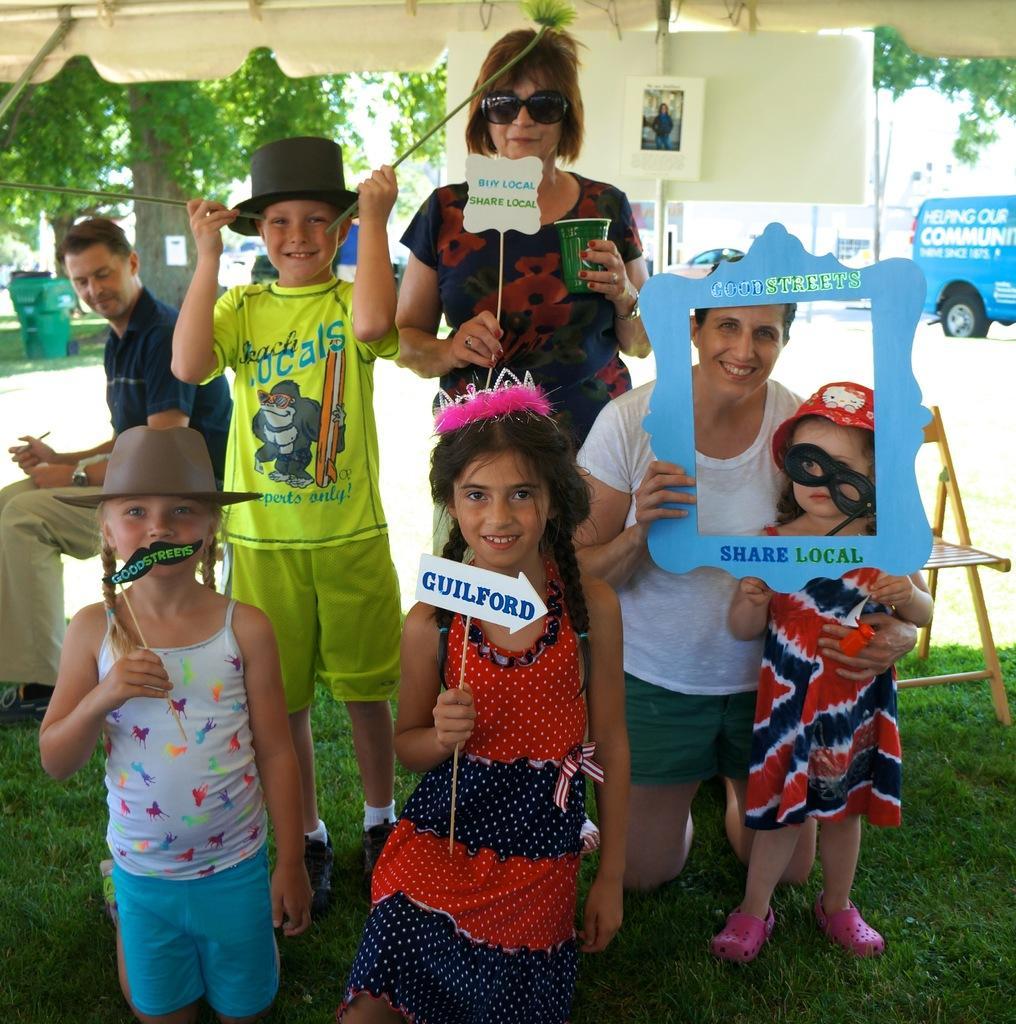Please provide a concise description of this image. In this image we can see a few people, some of them are holding some objects, few of them are holding boards with text on it, a lady is holding a glass, there is a person holding a pen, there are chairs, trees, a dustbin, there is a vehicle, and the grass. 